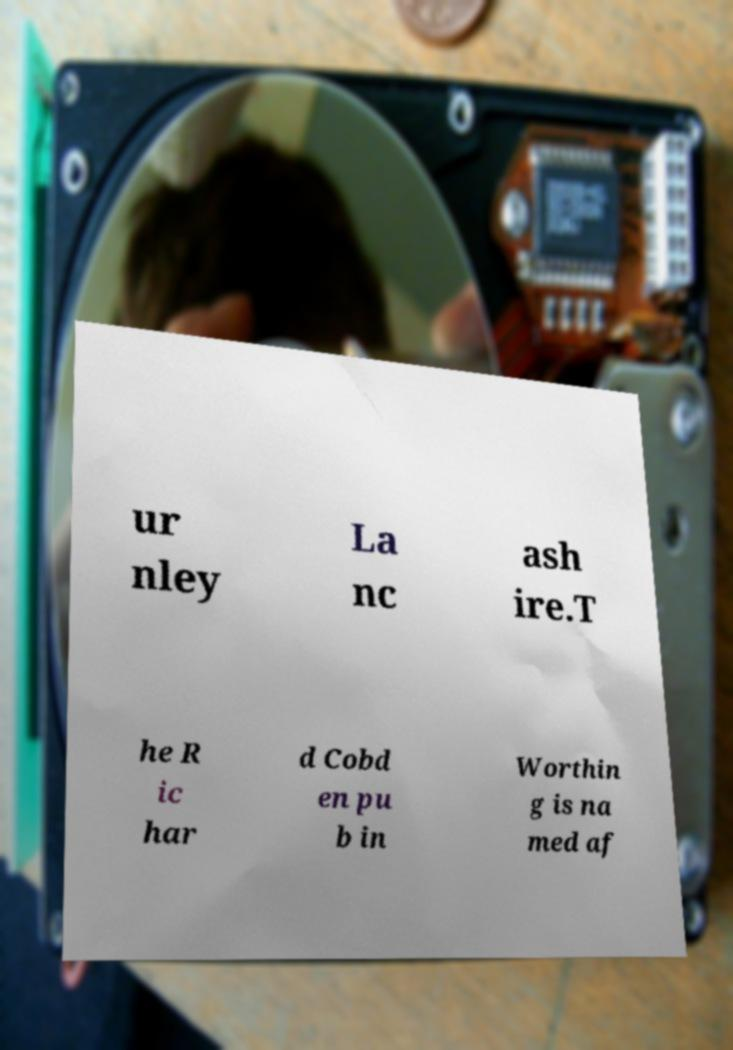Please read and relay the text visible in this image. What does it say? ur nley La nc ash ire.T he R ic har d Cobd en pu b in Worthin g is na med af 